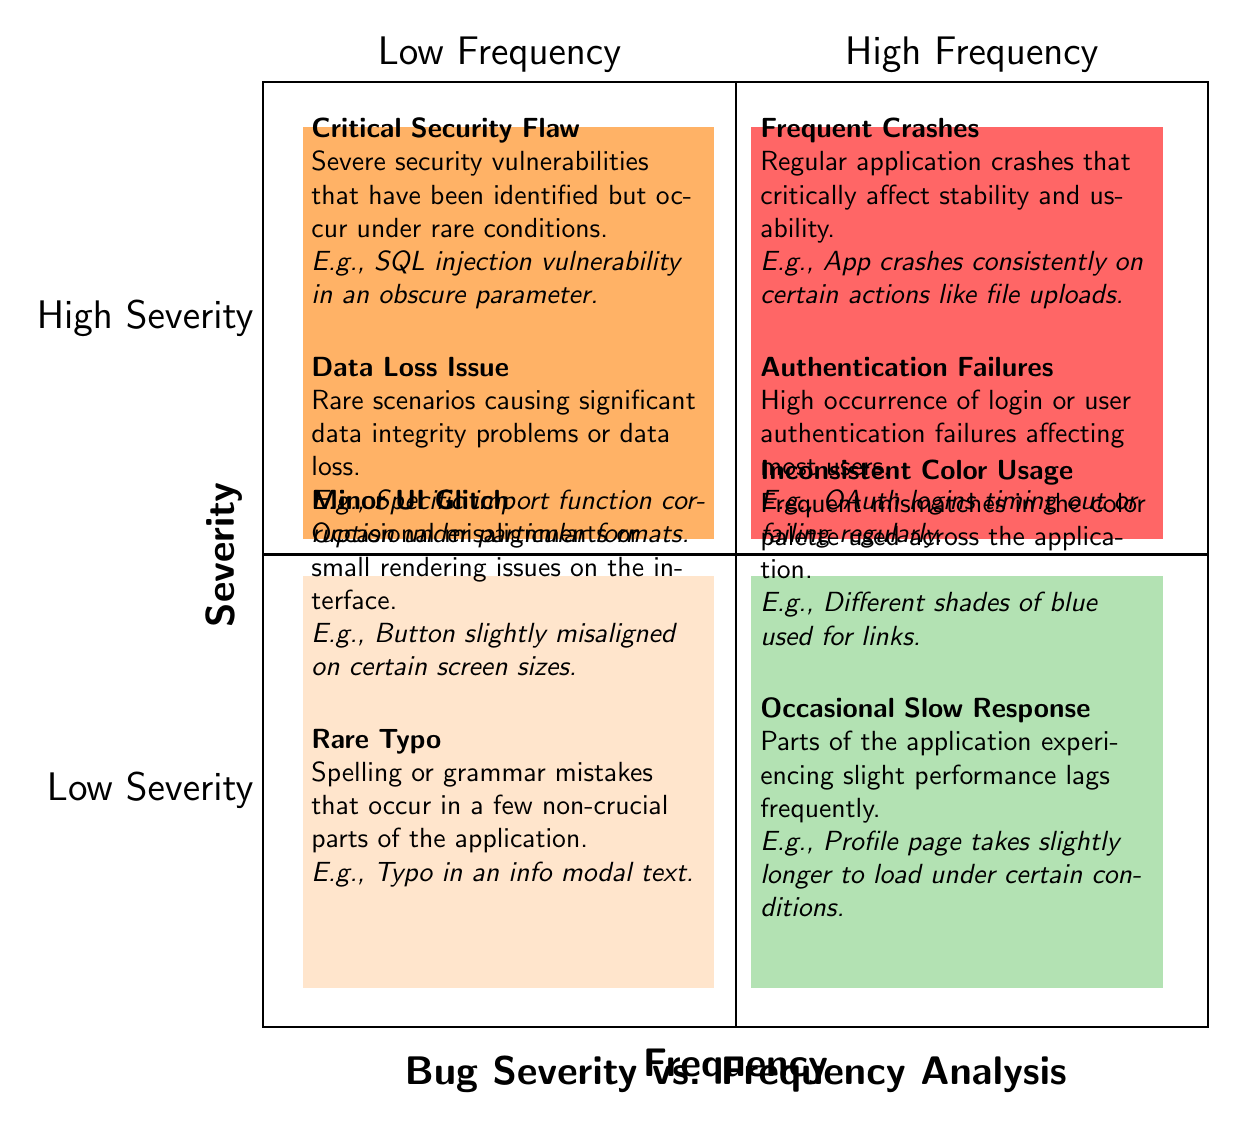What type of bug appears in the Low Frequency, Low Severity quadrant? There are two types of bugs in this quadrant: "Minor UI Glitch" and "Rare Typo." Both are categorized as low frequency and low severity issues.
Answer: Minor UI Glitch, Rare Typo How many types of bugs are represented in the High Frequency, High Severity quadrant? In this quadrant, there are two types of bugs: "Frequent Crashes" and "Authentication Failures." This indicates a combination of high occurrence and high impact.
Answer: 2 Which bug in the Low Frequency, High Severity quadrant is related to security? The bug titled "Critical Security Flaw" is categorized under low frequency and high severity, indicating a serious security issue that appears rarely.
Answer: Critical Security Flaw In which quadrant can you find the most frequent performance issue? The "Occasional Slow Response" bug, which indicates frequency as well as less criticality, is located in the High Frequency, Low Severity quadrant.
Answer: High Frequency, Low Severity What are the examples given for the "Frequent Crashes" issue? The example provided states that the app crashes consistently on certain actions like file uploads, illustrating a critical usability problem.
Answer: App crashes consistently on certain actions like file uploads Which quadrant contains bugs that are both common and serious? The quadrant titled High Frequency, High Severity includes bugs that are encountered often and have significant consequences. It contains bugs like "Frequent Crashes" and "Authentication Failures."
Answer: High Frequency, High Severity What is the characteristic example of the "Data Loss Issue"? This issue is described as causing significant data integrity problems or data loss in rare scenarios and is categorized under low frequency and high severity.
Answer: Specific import function corruption under particular formats Which type of bug has an example related to interface rendering issues? The "Minor UI Glitch" is related to occasional rendering issues on the interface, and it is situated in the Low Frequency, Low Severity quadrant.
Answer: Minor UI Glitch 